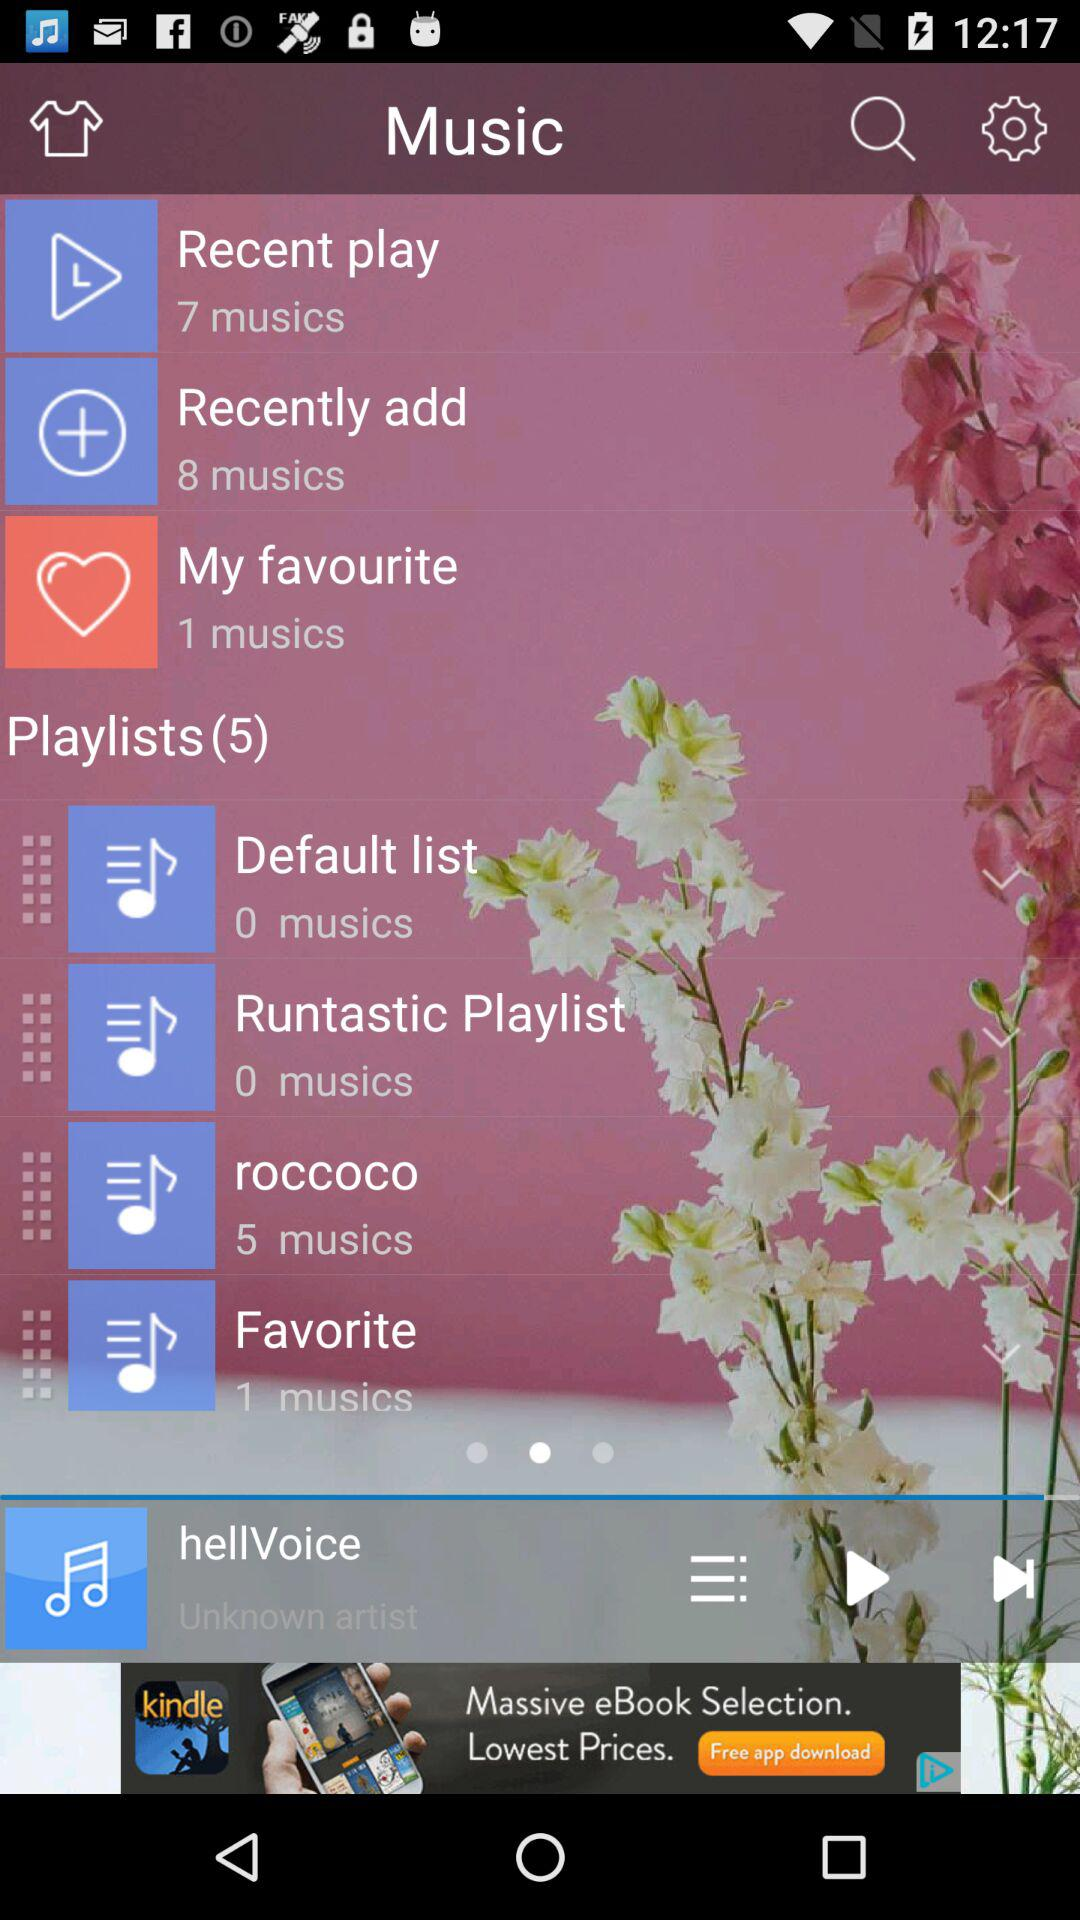How many musics are there in the "Recently add" list? There are 8 musics added. 